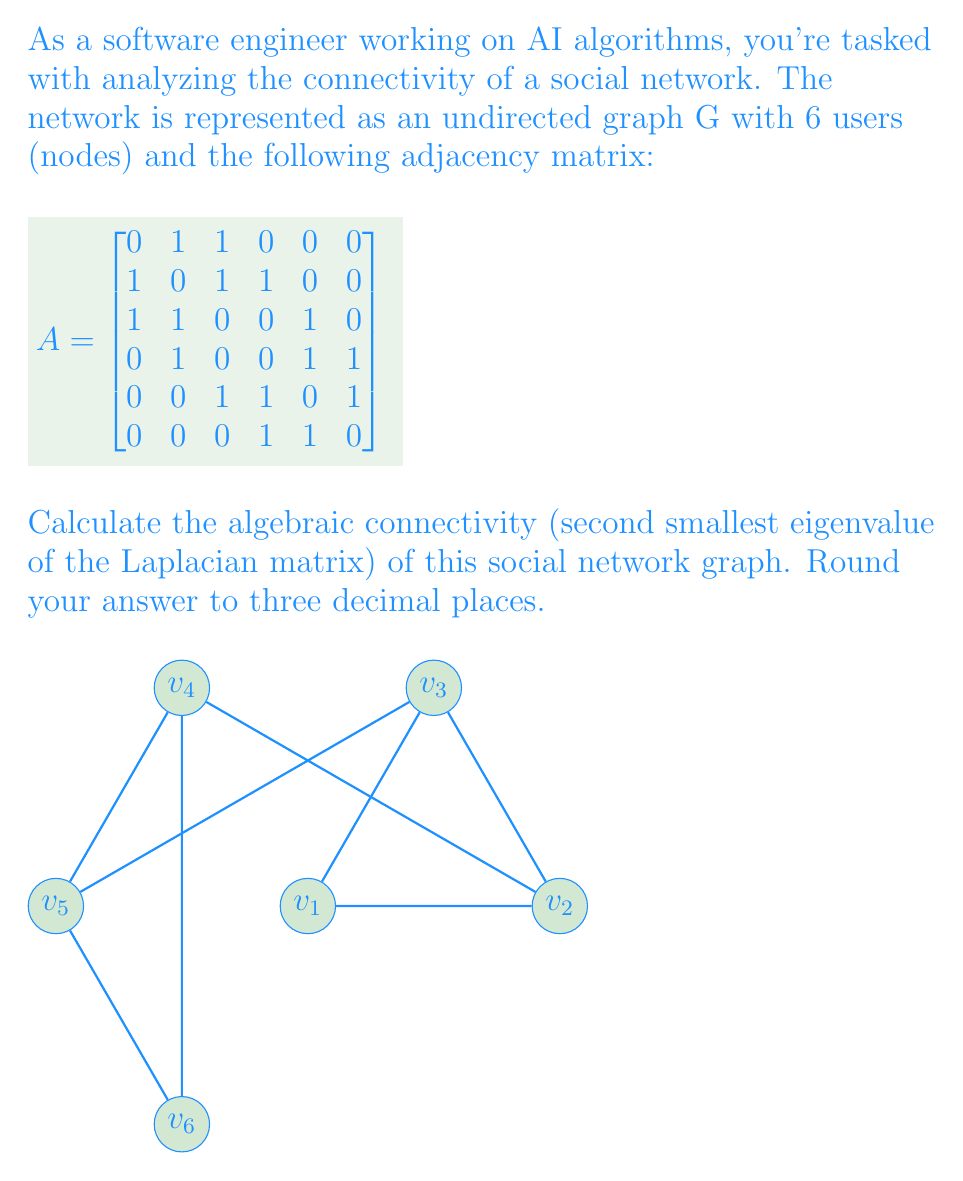Teach me how to tackle this problem. Let's approach this step-by-step:

1) First, we need to calculate the Laplacian matrix L. The Laplacian matrix is defined as L = D - A, where D is the degree matrix and A is the adjacency matrix.

2) The degree matrix D is a diagonal matrix where each entry $d_{ii}$ is the degree of vertex i:

   $$
   D = \begin{bmatrix}
   2 & 0 & 0 & 0 & 0 & 0 \\
   0 & 3 & 0 & 0 & 0 & 0 \\
   0 & 0 & 3 & 0 & 0 & 0 \\
   0 & 0 & 0 & 3 & 0 & 0 \\
   0 & 0 & 0 & 0 & 3 & 0 \\
   0 & 0 & 0 & 0 & 0 & 2
   \end{bmatrix}
   $$

3) Now we can calculate the Laplacian matrix L = D - A:

   $$
   L = \begin{bmatrix}
   2 & -1 & -1 & 0 & 0 & 0 \\
   -1 & 3 & -1 & -1 & 0 & 0 \\
   -1 & -1 & 3 & 0 & -1 & 0 \\
   0 & -1 & 0 & 3 & -1 & -1 \\
   0 & 0 & -1 & -1 & 3 & -1 \\
   0 & 0 & 0 & -1 & -1 & 2
   \end{bmatrix}
   $$

4) To find the eigenvalues of L, we need to solve the characteristic equation det(L - λI) = 0. This is a 6th degree polynomial equation, which is challenging to solve by hand.

5) Using computational tools (e.g., Python with NumPy), we can calculate the eigenvalues:

   λ₁ ≈ 0
   λ₂ ≈ 0.7639
   λ₃ ≈ 2.0000
   λ₄ ≈ 3.0000
   λ₅ ≈ 3.2361
   λ₆ ≈ 5.0000

6) The algebraic connectivity is the second smallest eigenvalue, which is λ₂ ≈ 0.7639.

7) Rounding to three decimal places, we get 0.764.
Answer: 0.764 